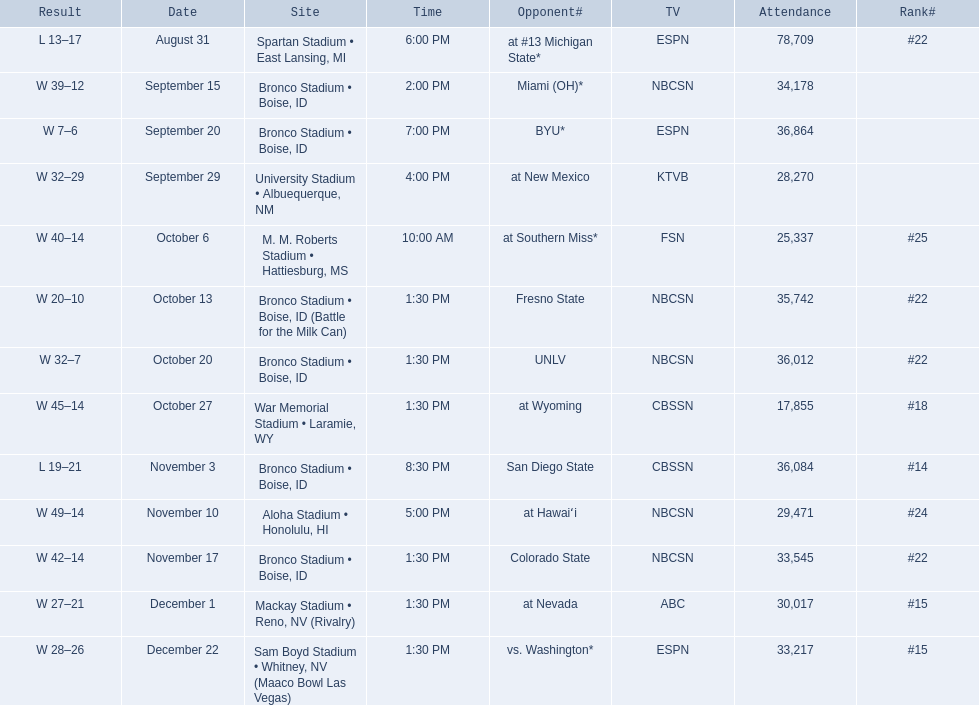What are all of the rankings? #22, , , , #25, #22, #22, #18, #14, #24, #22, #15, #15. Which of them was the best position? #14. 